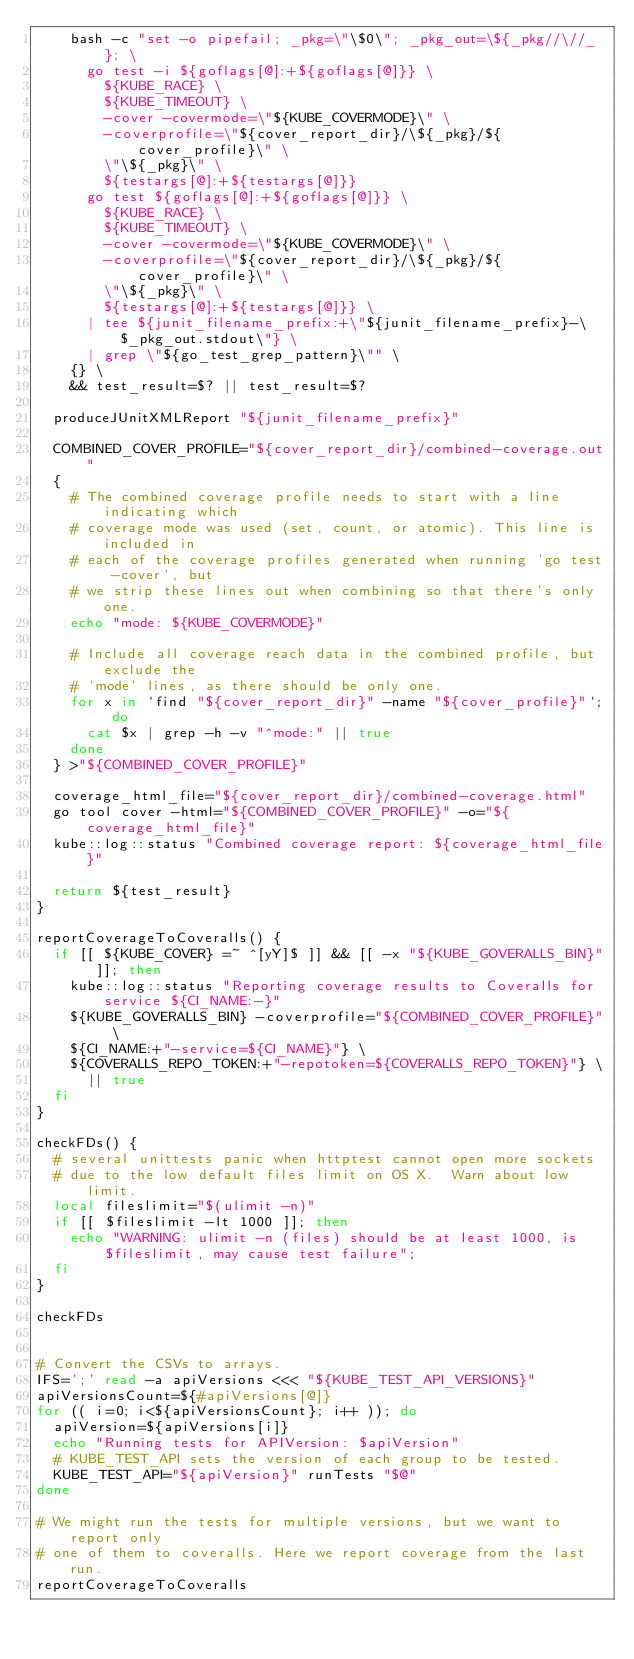<code> <loc_0><loc_0><loc_500><loc_500><_Bash_>    bash -c "set -o pipefail; _pkg=\"\$0\"; _pkg_out=\${_pkg//\//_}; \
      go test -i ${goflags[@]:+${goflags[@]}} \
        ${KUBE_RACE} \
        ${KUBE_TIMEOUT} \
        -cover -covermode=\"${KUBE_COVERMODE}\" \
        -coverprofile=\"${cover_report_dir}/\${_pkg}/${cover_profile}\" \
        \"\${_pkg}\" \
        ${testargs[@]:+${testargs[@]}}
      go test ${goflags[@]:+${goflags[@]}} \
        ${KUBE_RACE} \
        ${KUBE_TIMEOUT} \
        -cover -covermode=\"${KUBE_COVERMODE}\" \
        -coverprofile=\"${cover_report_dir}/\${_pkg}/${cover_profile}\" \
        \"\${_pkg}\" \
        ${testargs[@]:+${testargs[@]}} \
      | tee ${junit_filename_prefix:+\"${junit_filename_prefix}-\$_pkg_out.stdout\"} \
      | grep \"${go_test_grep_pattern}\"" \
    {} \
    && test_result=$? || test_result=$?

  produceJUnitXMLReport "${junit_filename_prefix}"

  COMBINED_COVER_PROFILE="${cover_report_dir}/combined-coverage.out"
  {
    # The combined coverage profile needs to start with a line indicating which
    # coverage mode was used (set, count, or atomic). This line is included in
    # each of the coverage profiles generated when running 'go test -cover', but
    # we strip these lines out when combining so that there's only one.
    echo "mode: ${KUBE_COVERMODE}"

    # Include all coverage reach data in the combined profile, but exclude the
    # 'mode' lines, as there should be only one.
    for x in `find "${cover_report_dir}" -name "${cover_profile}"`; do
      cat $x | grep -h -v "^mode:" || true
    done
  } >"${COMBINED_COVER_PROFILE}"

  coverage_html_file="${cover_report_dir}/combined-coverage.html"
  go tool cover -html="${COMBINED_COVER_PROFILE}" -o="${coverage_html_file}"
  kube::log::status "Combined coverage report: ${coverage_html_file}"

  return ${test_result}
}

reportCoverageToCoveralls() {
  if [[ ${KUBE_COVER} =~ ^[yY]$ ]] && [[ -x "${KUBE_GOVERALLS_BIN}" ]]; then
    kube::log::status "Reporting coverage results to Coveralls for service ${CI_NAME:-}"
    ${KUBE_GOVERALLS_BIN} -coverprofile="${COMBINED_COVER_PROFILE}" \
    ${CI_NAME:+"-service=${CI_NAME}"} \
    ${COVERALLS_REPO_TOKEN:+"-repotoken=${COVERALLS_REPO_TOKEN}"} \
      || true
  fi
}

checkFDs() {
  # several unittests panic when httptest cannot open more sockets
  # due to the low default files limit on OS X.  Warn about low limit.
  local fileslimit="$(ulimit -n)"
  if [[ $fileslimit -lt 1000 ]]; then
    echo "WARNING: ulimit -n (files) should be at least 1000, is $fileslimit, may cause test failure";
  fi
}

checkFDs


# Convert the CSVs to arrays.
IFS=';' read -a apiVersions <<< "${KUBE_TEST_API_VERSIONS}"
apiVersionsCount=${#apiVersions[@]}
for (( i=0; i<${apiVersionsCount}; i++ )); do
  apiVersion=${apiVersions[i]}
  echo "Running tests for APIVersion: $apiVersion"
  # KUBE_TEST_API sets the version of each group to be tested.
  KUBE_TEST_API="${apiVersion}" runTests "$@"
done

# We might run the tests for multiple versions, but we want to report only
# one of them to coveralls. Here we report coverage from the last run.
reportCoverageToCoveralls
</code> 